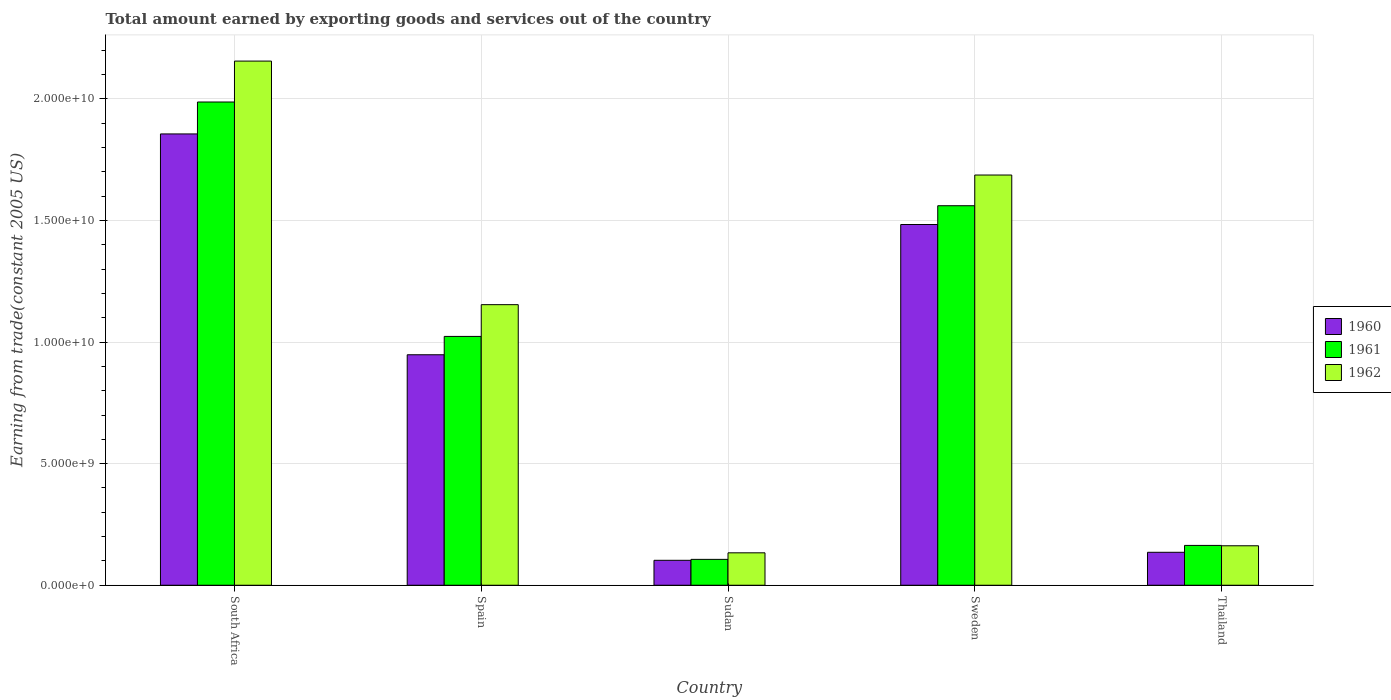What is the total amount earned by exporting goods and services in 1961 in Thailand?
Offer a very short reply. 1.64e+09. Across all countries, what is the maximum total amount earned by exporting goods and services in 1962?
Make the answer very short. 2.16e+1. Across all countries, what is the minimum total amount earned by exporting goods and services in 1962?
Offer a terse response. 1.33e+09. In which country was the total amount earned by exporting goods and services in 1962 maximum?
Give a very brief answer. South Africa. In which country was the total amount earned by exporting goods and services in 1961 minimum?
Give a very brief answer. Sudan. What is the total total amount earned by exporting goods and services in 1961 in the graph?
Give a very brief answer. 4.84e+1. What is the difference between the total amount earned by exporting goods and services in 1962 in South Africa and that in Thailand?
Give a very brief answer. 1.99e+1. What is the difference between the total amount earned by exporting goods and services in 1961 in Sweden and the total amount earned by exporting goods and services in 1962 in Sudan?
Provide a succinct answer. 1.43e+1. What is the average total amount earned by exporting goods and services in 1960 per country?
Offer a terse response. 9.05e+09. What is the difference between the total amount earned by exporting goods and services of/in 1962 and total amount earned by exporting goods and services of/in 1960 in Thailand?
Make the answer very short. 2.68e+08. In how many countries, is the total amount earned by exporting goods and services in 1962 greater than 3000000000 US$?
Provide a short and direct response. 3. What is the ratio of the total amount earned by exporting goods and services in 1960 in South Africa to that in Thailand?
Your answer should be very brief. 13.7. Is the difference between the total amount earned by exporting goods and services in 1962 in Spain and Thailand greater than the difference between the total amount earned by exporting goods and services in 1960 in Spain and Thailand?
Your response must be concise. Yes. What is the difference between the highest and the second highest total amount earned by exporting goods and services in 1960?
Ensure brevity in your answer.  9.08e+09. What is the difference between the highest and the lowest total amount earned by exporting goods and services in 1960?
Your response must be concise. 1.75e+1. What does the 1st bar from the left in Thailand represents?
Offer a terse response. 1960. What does the 2nd bar from the right in Spain represents?
Your answer should be very brief. 1961. How many bars are there?
Your answer should be very brief. 15. How many countries are there in the graph?
Your answer should be compact. 5. Does the graph contain any zero values?
Give a very brief answer. No. Does the graph contain grids?
Make the answer very short. Yes. What is the title of the graph?
Make the answer very short. Total amount earned by exporting goods and services out of the country. What is the label or title of the X-axis?
Offer a very short reply. Country. What is the label or title of the Y-axis?
Offer a very short reply. Earning from trade(constant 2005 US). What is the Earning from trade(constant 2005 US) in 1960 in South Africa?
Provide a succinct answer. 1.86e+1. What is the Earning from trade(constant 2005 US) of 1961 in South Africa?
Ensure brevity in your answer.  1.99e+1. What is the Earning from trade(constant 2005 US) in 1962 in South Africa?
Your response must be concise. 2.16e+1. What is the Earning from trade(constant 2005 US) in 1960 in Spain?
Ensure brevity in your answer.  9.48e+09. What is the Earning from trade(constant 2005 US) in 1961 in Spain?
Provide a succinct answer. 1.02e+1. What is the Earning from trade(constant 2005 US) in 1962 in Spain?
Your answer should be compact. 1.15e+1. What is the Earning from trade(constant 2005 US) of 1960 in Sudan?
Your answer should be very brief. 1.03e+09. What is the Earning from trade(constant 2005 US) of 1961 in Sudan?
Ensure brevity in your answer.  1.06e+09. What is the Earning from trade(constant 2005 US) in 1962 in Sudan?
Keep it short and to the point. 1.33e+09. What is the Earning from trade(constant 2005 US) of 1960 in Sweden?
Your answer should be very brief. 1.48e+1. What is the Earning from trade(constant 2005 US) in 1961 in Sweden?
Your response must be concise. 1.56e+1. What is the Earning from trade(constant 2005 US) in 1962 in Sweden?
Provide a succinct answer. 1.69e+1. What is the Earning from trade(constant 2005 US) in 1960 in Thailand?
Your answer should be compact. 1.35e+09. What is the Earning from trade(constant 2005 US) of 1961 in Thailand?
Offer a very short reply. 1.64e+09. What is the Earning from trade(constant 2005 US) in 1962 in Thailand?
Provide a short and direct response. 1.62e+09. Across all countries, what is the maximum Earning from trade(constant 2005 US) of 1960?
Your answer should be compact. 1.86e+1. Across all countries, what is the maximum Earning from trade(constant 2005 US) in 1961?
Provide a succinct answer. 1.99e+1. Across all countries, what is the maximum Earning from trade(constant 2005 US) of 1962?
Ensure brevity in your answer.  2.16e+1. Across all countries, what is the minimum Earning from trade(constant 2005 US) in 1960?
Your answer should be compact. 1.03e+09. Across all countries, what is the minimum Earning from trade(constant 2005 US) of 1961?
Offer a very short reply. 1.06e+09. Across all countries, what is the minimum Earning from trade(constant 2005 US) of 1962?
Provide a short and direct response. 1.33e+09. What is the total Earning from trade(constant 2005 US) in 1960 in the graph?
Your response must be concise. 4.53e+1. What is the total Earning from trade(constant 2005 US) of 1961 in the graph?
Your answer should be very brief. 4.84e+1. What is the total Earning from trade(constant 2005 US) in 1962 in the graph?
Your response must be concise. 5.29e+1. What is the difference between the Earning from trade(constant 2005 US) of 1960 in South Africa and that in Spain?
Provide a short and direct response. 9.08e+09. What is the difference between the Earning from trade(constant 2005 US) in 1961 in South Africa and that in Spain?
Give a very brief answer. 9.64e+09. What is the difference between the Earning from trade(constant 2005 US) of 1962 in South Africa and that in Spain?
Ensure brevity in your answer.  1.00e+1. What is the difference between the Earning from trade(constant 2005 US) of 1960 in South Africa and that in Sudan?
Provide a succinct answer. 1.75e+1. What is the difference between the Earning from trade(constant 2005 US) in 1961 in South Africa and that in Sudan?
Your response must be concise. 1.88e+1. What is the difference between the Earning from trade(constant 2005 US) of 1962 in South Africa and that in Sudan?
Your answer should be very brief. 2.02e+1. What is the difference between the Earning from trade(constant 2005 US) in 1960 in South Africa and that in Sweden?
Your answer should be very brief. 3.72e+09. What is the difference between the Earning from trade(constant 2005 US) in 1961 in South Africa and that in Sweden?
Keep it short and to the point. 4.27e+09. What is the difference between the Earning from trade(constant 2005 US) of 1962 in South Africa and that in Sweden?
Provide a short and direct response. 4.69e+09. What is the difference between the Earning from trade(constant 2005 US) in 1960 in South Africa and that in Thailand?
Provide a succinct answer. 1.72e+1. What is the difference between the Earning from trade(constant 2005 US) of 1961 in South Africa and that in Thailand?
Provide a succinct answer. 1.82e+1. What is the difference between the Earning from trade(constant 2005 US) of 1962 in South Africa and that in Thailand?
Your answer should be compact. 1.99e+1. What is the difference between the Earning from trade(constant 2005 US) of 1960 in Spain and that in Sudan?
Offer a terse response. 8.45e+09. What is the difference between the Earning from trade(constant 2005 US) of 1961 in Spain and that in Sudan?
Your response must be concise. 9.17e+09. What is the difference between the Earning from trade(constant 2005 US) of 1962 in Spain and that in Sudan?
Offer a terse response. 1.02e+1. What is the difference between the Earning from trade(constant 2005 US) in 1960 in Spain and that in Sweden?
Give a very brief answer. -5.36e+09. What is the difference between the Earning from trade(constant 2005 US) of 1961 in Spain and that in Sweden?
Your answer should be compact. -5.37e+09. What is the difference between the Earning from trade(constant 2005 US) in 1962 in Spain and that in Sweden?
Provide a succinct answer. -5.33e+09. What is the difference between the Earning from trade(constant 2005 US) in 1960 in Spain and that in Thailand?
Make the answer very short. 8.12e+09. What is the difference between the Earning from trade(constant 2005 US) in 1961 in Spain and that in Thailand?
Provide a succinct answer. 8.59e+09. What is the difference between the Earning from trade(constant 2005 US) of 1962 in Spain and that in Thailand?
Provide a succinct answer. 9.92e+09. What is the difference between the Earning from trade(constant 2005 US) of 1960 in Sudan and that in Sweden?
Offer a very short reply. -1.38e+1. What is the difference between the Earning from trade(constant 2005 US) of 1961 in Sudan and that in Sweden?
Offer a very short reply. -1.45e+1. What is the difference between the Earning from trade(constant 2005 US) in 1962 in Sudan and that in Sweden?
Make the answer very short. -1.55e+1. What is the difference between the Earning from trade(constant 2005 US) in 1960 in Sudan and that in Thailand?
Provide a short and direct response. -3.29e+08. What is the difference between the Earning from trade(constant 2005 US) of 1961 in Sudan and that in Thailand?
Provide a succinct answer. -5.74e+08. What is the difference between the Earning from trade(constant 2005 US) in 1962 in Sudan and that in Thailand?
Give a very brief answer. -2.89e+08. What is the difference between the Earning from trade(constant 2005 US) in 1960 in Sweden and that in Thailand?
Keep it short and to the point. 1.35e+1. What is the difference between the Earning from trade(constant 2005 US) in 1961 in Sweden and that in Thailand?
Make the answer very short. 1.40e+1. What is the difference between the Earning from trade(constant 2005 US) in 1962 in Sweden and that in Thailand?
Ensure brevity in your answer.  1.52e+1. What is the difference between the Earning from trade(constant 2005 US) of 1960 in South Africa and the Earning from trade(constant 2005 US) of 1961 in Spain?
Your answer should be very brief. 8.33e+09. What is the difference between the Earning from trade(constant 2005 US) in 1960 in South Africa and the Earning from trade(constant 2005 US) in 1962 in Spain?
Provide a succinct answer. 7.02e+09. What is the difference between the Earning from trade(constant 2005 US) of 1961 in South Africa and the Earning from trade(constant 2005 US) of 1962 in Spain?
Your answer should be very brief. 8.33e+09. What is the difference between the Earning from trade(constant 2005 US) of 1960 in South Africa and the Earning from trade(constant 2005 US) of 1961 in Sudan?
Your answer should be very brief. 1.75e+1. What is the difference between the Earning from trade(constant 2005 US) of 1960 in South Africa and the Earning from trade(constant 2005 US) of 1962 in Sudan?
Give a very brief answer. 1.72e+1. What is the difference between the Earning from trade(constant 2005 US) of 1961 in South Africa and the Earning from trade(constant 2005 US) of 1962 in Sudan?
Offer a very short reply. 1.85e+1. What is the difference between the Earning from trade(constant 2005 US) in 1960 in South Africa and the Earning from trade(constant 2005 US) in 1961 in Sweden?
Provide a short and direct response. 2.95e+09. What is the difference between the Earning from trade(constant 2005 US) of 1960 in South Africa and the Earning from trade(constant 2005 US) of 1962 in Sweden?
Provide a short and direct response. 1.69e+09. What is the difference between the Earning from trade(constant 2005 US) of 1961 in South Africa and the Earning from trade(constant 2005 US) of 1962 in Sweden?
Your response must be concise. 3.00e+09. What is the difference between the Earning from trade(constant 2005 US) in 1960 in South Africa and the Earning from trade(constant 2005 US) in 1961 in Thailand?
Provide a succinct answer. 1.69e+1. What is the difference between the Earning from trade(constant 2005 US) of 1960 in South Africa and the Earning from trade(constant 2005 US) of 1962 in Thailand?
Offer a terse response. 1.69e+1. What is the difference between the Earning from trade(constant 2005 US) in 1961 in South Africa and the Earning from trade(constant 2005 US) in 1962 in Thailand?
Provide a succinct answer. 1.82e+1. What is the difference between the Earning from trade(constant 2005 US) of 1960 in Spain and the Earning from trade(constant 2005 US) of 1961 in Sudan?
Ensure brevity in your answer.  8.41e+09. What is the difference between the Earning from trade(constant 2005 US) of 1960 in Spain and the Earning from trade(constant 2005 US) of 1962 in Sudan?
Your answer should be very brief. 8.14e+09. What is the difference between the Earning from trade(constant 2005 US) of 1961 in Spain and the Earning from trade(constant 2005 US) of 1962 in Sudan?
Your answer should be compact. 8.90e+09. What is the difference between the Earning from trade(constant 2005 US) in 1960 in Spain and the Earning from trade(constant 2005 US) in 1961 in Sweden?
Your answer should be very brief. -6.13e+09. What is the difference between the Earning from trade(constant 2005 US) of 1960 in Spain and the Earning from trade(constant 2005 US) of 1962 in Sweden?
Make the answer very short. -7.39e+09. What is the difference between the Earning from trade(constant 2005 US) in 1961 in Spain and the Earning from trade(constant 2005 US) in 1962 in Sweden?
Ensure brevity in your answer.  -6.64e+09. What is the difference between the Earning from trade(constant 2005 US) in 1960 in Spain and the Earning from trade(constant 2005 US) in 1961 in Thailand?
Ensure brevity in your answer.  7.84e+09. What is the difference between the Earning from trade(constant 2005 US) of 1960 in Spain and the Earning from trade(constant 2005 US) of 1962 in Thailand?
Your answer should be very brief. 7.86e+09. What is the difference between the Earning from trade(constant 2005 US) in 1961 in Spain and the Earning from trade(constant 2005 US) in 1962 in Thailand?
Give a very brief answer. 8.61e+09. What is the difference between the Earning from trade(constant 2005 US) of 1960 in Sudan and the Earning from trade(constant 2005 US) of 1961 in Sweden?
Offer a very short reply. -1.46e+1. What is the difference between the Earning from trade(constant 2005 US) in 1960 in Sudan and the Earning from trade(constant 2005 US) in 1962 in Sweden?
Make the answer very short. -1.58e+1. What is the difference between the Earning from trade(constant 2005 US) in 1961 in Sudan and the Earning from trade(constant 2005 US) in 1962 in Sweden?
Offer a terse response. -1.58e+1. What is the difference between the Earning from trade(constant 2005 US) in 1960 in Sudan and the Earning from trade(constant 2005 US) in 1961 in Thailand?
Offer a terse response. -6.12e+08. What is the difference between the Earning from trade(constant 2005 US) in 1960 in Sudan and the Earning from trade(constant 2005 US) in 1962 in Thailand?
Give a very brief answer. -5.97e+08. What is the difference between the Earning from trade(constant 2005 US) of 1961 in Sudan and the Earning from trade(constant 2005 US) of 1962 in Thailand?
Give a very brief answer. -5.59e+08. What is the difference between the Earning from trade(constant 2005 US) in 1960 in Sweden and the Earning from trade(constant 2005 US) in 1961 in Thailand?
Make the answer very short. 1.32e+1. What is the difference between the Earning from trade(constant 2005 US) of 1960 in Sweden and the Earning from trade(constant 2005 US) of 1962 in Thailand?
Offer a very short reply. 1.32e+1. What is the difference between the Earning from trade(constant 2005 US) of 1961 in Sweden and the Earning from trade(constant 2005 US) of 1962 in Thailand?
Ensure brevity in your answer.  1.40e+1. What is the average Earning from trade(constant 2005 US) of 1960 per country?
Your answer should be compact. 9.05e+09. What is the average Earning from trade(constant 2005 US) in 1961 per country?
Provide a short and direct response. 9.68e+09. What is the average Earning from trade(constant 2005 US) of 1962 per country?
Provide a succinct answer. 1.06e+1. What is the difference between the Earning from trade(constant 2005 US) of 1960 and Earning from trade(constant 2005 US) of 1961 in South Africa?
Your answer should be compact. -1.31e+09. What is the difference between the Earning from trade(constant 2005 US) of 1960 and Earning from trade(constant 2005 US) of 1962 in South Africa?
Your answer should be compact. -3.00e+09. What is the difference between the Earning from trade(constant 2005 US) of 1961 and Earning from trade(constant 2005 US) of 1962 in South Africa?
Offer a terse response. -1.68e+09. What is the difference between the Earning from trade(constant 2005 US) in 1960 and Earning from trade(constant 2005 US) in 1961 in Spain?
Provide a short and direct response. -7.54e+08. What is the difference between the Earning from trade(constant 2005 US) in 1960 and Earning from trade(constant 2005 US) in 1962 in Spain?
Keep it short and to the point. -2.06e+09. What is the difference between the Earning from trade(constant 2005 US) of 1961 and Earning from trade(constant 2005 US) of 1962 in Spain?
Make the answer very short. -1.31e+09. What is the difference between the Earning from trade(constant 2005 US) of 1960 and Earning from trade(constant 2005 US) of 1961 in Sudan?
Make the answer very short. -3.85e+07. What is the difference between the Earning from trade(constant 2005 US) of 1960 and Earning from trade(constant 2005 US) of 1962 in Sudan?
Your answer should be compact. -3.08e+08. What is the difference between the Earning from trade(constant 2005 US) in 1961 and Earning from trade(constant 2005 US) in 1962 in Sudan?
Make the answer very short. -2.69e+08. What is the difference between the Earning from trade(constant 2005 US) of 1960 and Earning from trade(constant 2005 US) of 1961 in Sweden?
Offer a terse response. -7.72e+08. What is the difference between the Earning from trade(constant 2005 US) in 1960 and Earning from trade(constant 2005 US) in 1962 in Sweden?
Give a very brief answer. -2.03e+09. What is the difference between the Earning from trade(constant 2005 US) of 1961 and Earning from trade(constant 2005 US) of 1962 in Sweden?
Provide a succinct answer. -1.26e+09. What is the difference between the Earning from trade(constant 2005 US) of 1960 and Earning from trade(constant 2005 US) of 1961 in Thailand?
Your answer should be compact. -2.83e+08. What is the difference between the Earning from trade(constant 2005 US) in 1960 and Earning from trade(constant 2005 US) in 1962 in Thailand?
Give a very brief answer. -2.68e+08. What is the difference between the Earning from trade(constant 2005 US) in 1961 and Earning from trade(constant 2005 US) in 1962 in Thailand?
Your answer should be very brief. 1.49e+07. What is the ratio of the Earning from trade(constant 2005 US) of 1960 in South Africa to that in Spain?
Offer a very short reply. 1.96. What is the ratio of the Earning from trade(constant 2005 US) in 1961 in South Africa to that in Spain?
Make the answer very short. 1.94. What is the ratio of the Earning from trade(constant 2005 US) in 1962 in South Africa to that in Spain?
Provide a short and direct response. 1.87. What is the ratio of the Earning from trade(constant 2005 US) of 1960 in South Africa to that in Sudan?
Offer a terse response. 18.1. What is the ratio of the Earning from trade(constant 2005 US) of 1961 in South Africa to that in Sudan?
Your answer should be very brief. 18.68. What is the ratio of the Earning from trade(constant 2005 US) in 1962 in South Africa to that in Sudan?
Your answer should be very brief. 16.17. What is the ratio of the Earning from trade(constant 2005 US) in 1960 in South Africa to that in Sweden?
Provide a short and direct response. 1.25. What is the ratio of the Earning from trade(constant 2005 US) of 1961 in South Africa to that in Sweden?
Your response must be concise. 1.27. What is the ratio of the Earning from trade(constant 2005 US) in 1962 in South Africa to that in Sweden?
Give a very brief answer. 1.28. What is the ratio of the Earning from trade(constant 2005 US) in 1960 in South Africa to that in Thailand?
Your response must be concise. 13.7. What is the ratio of the Earning from trade(constant 2005 US) in 1961 in South Africa to that in Thailand?
Your answer should be compact. 12.13. What is the ratio of the Earning from trade(constant 2005 US) in 1962 in South Africa to that in Thailand?
Offer a very short reply. 13.28. What is the ratio of the Earning from trade(constant 2005 US) in 1960 in Spain to that in Sudan?
Your answer should be compact. 9.24. What is the ratio of the Earning from trade(constant 2005 US) in 1961 in Spain to that in Sudan?
Keep it short and to the point. 9.62. What is the ratio of the Earning from trade(constant 2005 US) in 1962 in Spain to that in Sudan?
Provide a succinct answer. 8.65. What is the ratio of the Earning from trade(constant 2005 US) in 1960 in Spain to that in Sweden?
Offer a terse response. 0.64. What is the ratio of the Earning from trade(constant 2005 US) of 1961 in Spain to that in Sweden?
Your response must be concise. 0.66. What is the ratio of the Earning from trade(constant 2005 US) of 1962 in Spain to that in Sweden?
Your answer should be very brief. 0.68. What is the ratio of the Earning from trade(constant 2005 US) in 1960 in Spain to that in Thailand?
Offer a terse response. 7. What is the ratio of the Earning from trade(constant 2005 US) of 1961 in Spain to that in Thailand?
Make the answer very short. 6.25. What is the ratio of the Earning from trade(constant 2005 US) of 1962 in Spain to that in Thailand?
Give a very brief answer. 7.11. What is the ratio of the Earning from trade(constant 2005 US) in 1960 in Sudan to that in Sweden?
Give a very brief answer. 0.07. What is the ratio of the Earning from trade(constant 2005 US) in 1961 in Sudan to that in Sweden?
Your response must be concise. 0.07. What is the ratio of the Earning from trade(constant 2005 US) in 1962 in Sudan to that in Sweden?
Your answer should be very brief. 0.08. What is the ratio of the Earning from trade(constant 2005 US) in 1960 in Sudan to that in Thailand?
Offer a terse response. 0.76. What is the ratio of the Earning from trade(constant 2005 US) of 1961 in Sudan to that in Thailand?
Give a very brief answer. 0.65. What is the ratio of the Earning from trade(constant 2005 US) in 1962 in Sudan to that in Thailand?
Your answer should be very brief. 0.82. What is the ratio of the Earning from trade(constant 2005 US) in 1960 in Sweden to that in Thailand?
Provide a short and direct response. 10.95. What is the ratio of the Earning from trade(constant 2005 US) of 1961 in Sweden to that in Thailand?
Provide a succinct answer. 9.53. What is the ratio of the Earning from trade(constant 2005 US) in 1962 in Sweden to that in Thailand?
Your answer should be very brief. 10.4. What is the difference between the highest and the second highest Earning from trade(constant 2005 US) in 1960?
Offer a terse response. 3.72e+09. What is the difference between the highest and the second highest Earning from trade(constant 2005 US) of 1961?
Your response must be concise. 4.27e+09. What is the difference between the highest and the second highest Earning from trade(constant 2005 US) in 1962?
Offer a terse response. 4.69e+09. What is the difference between the highest and the lowest Earning from trade(constant 2005 US) in 1960?
Give a very brief answer. 1.75e+1. What is the difference between the highest and the lowest Earning from trade(constant 2005 US) in 1961?
Give a very brief answer. 1.88e+1. What is the difference between the highest and the lowest Earning from trade(constant 2005 US) of 1962?
Make the answer very short. 2.02e+1. 